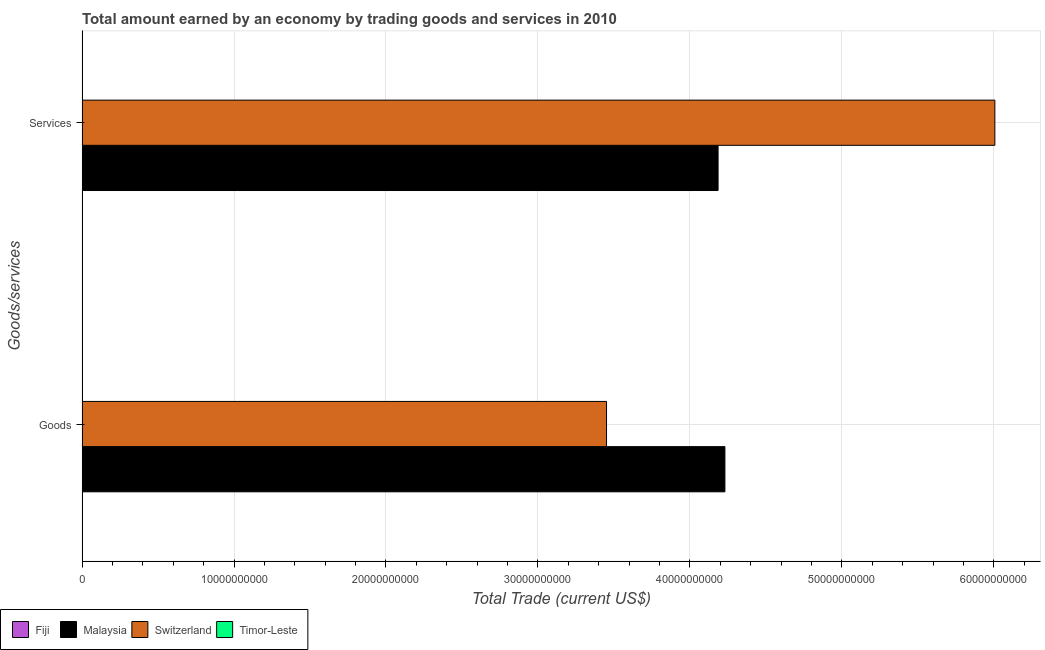How many groups of bars are there?
Make the answer very short. 2. Are the number of bars on each tick of the Y-axis equal?
Your answer should be compact. Yes. How many bars are there on the 1st tick from the top?
Your answer should be very brief. 2. What is the label of the 2nd group of bars from the top?
Offer a terse response. Goods. What is the amount earned by trading services in Timor-Leste?
Provide a succinct answer. 0. Across all countries, what is the maximum amount earned by trading services?
Provide a succinct answer. 6.01e+1. Across all countries, what is the minimum amount earned by trading goods?
Offer a very short reply. 0. In which country was the amount earned by trading services maximum?
Provide a short and direct response. Switzerland. What is the total amount earned by trading services in the graph?
Provide a short and direct response. 1.02e+11. What is the difference between the amount earned by trading goods in Switzerland and that in Malaysia?
Offer a terse response. -7.79e+09. What is the average amount earned by trading goods per country?
Your answer should be compact. 1.92e+1. What is the difference between the amount earned by trading services and amount earned by trading goods in Malaysia?
Offer a terse response. -4.50e+08. What is the ratio of the amount earned by trading goods in Switzerland to that in Malaysia?
Ensure brevity in your answer.  0.82. Is the amount earned by trading services in Malaysia less than that in Switzerland?
Ensure brevity in your answer.  Yes. How many bars are there?
Your answer should be compact. 4. Are all the bars in the graph horizontal?
Your answer should be very brief. Yes. How many countries are there in the graph?
Your answer should be very brief. 4. Are the values on the major ticks of X-axis written in scientific E-notation?
Provide a succinct answer. No. Does the graph contain any zero values?
Give a very brief answer. Yes. Where does the legend appear in the graph?
Give a very brief answer. Bottom left. How many legend labels are there?
Give a very brief answer. 4. What is the title of the graph?
Your answer should be compact. Total amount earned by an economy by trading goods and services in 2010. Does "Libya" appear as one of the legend labels in the graph?
Keep it short and to the point. No. What is the label or title of the X-axis?
Make the answer very short. Total Trade (current US$). What is the label or title of the Y-axis?
Make the answer very short. Goods/services. What is the Total Trade (current US$) in Fiji in Goods?
Offer a terse response. 0. What is the Total Trade (current US$) in Malaysia in Goods?
Ensure brevity in your answer.  4.23e+1. What is the Total Trade (current US$) of Switzerland in Goods?
Your answer should be compact. 3.45e+1. What is the Total Trade (current US$) in Timor-Leste in Goods?
Your answer should be compact. 0. What is the Total Trade (current US$) of Malaysia in Services?
Provide a short and direct response. 4.19e+1. What is the Total Trade (current US$) of Switzerland in Services?
Ensure brevity in your answer.  6.01e+1. Across all Goods/services, what is the maximum Total Trade (current US$) in Malaysia?
Ensure brevity in your answer.  4.23e+1. Across all Goods/services, what is the maximum Total Trade (current US$) in Switzerland?
Keep it short and to the point. 6.01e+1. Across all Goods/services, what is the minimum Total Trade (current US$) of Malaysia?
Your answer should be very brief. 4.19e+1. Across all Goods/services, what is the minimum Total Trade (current US$) of Switzerland?
Offer a terse response. 3.45e+1. What is the total Total Trade (current US$) in Fiji in the graph?
Provide a succinct answer. 0. What is the total Total Trade (current US$) of Malaysia in the graph?
Ensure brevity in your answer.  8.42e+1. What is the total Total Trade (current US$) in Switzerland in the graph?
Provide a succinct answer. 9.46e+1. What is the difference between the Total Trade (current US$) in Malaysia in Goods and that in Services?
Ensure brevity in your answer.  4.50e+08. What is the difference between the Total Trade (current US$) in Switzerland in Goods and that in Services?
Provide a short and direct response. -2.56e+1. What is the difference between the Total Trade (current US$) in Malaysia in Goods and the Total Trade (current US$) in Switzerland in Services?
Your answer should be compact. -1.78e+1. What is the average Total Trade (current US$) in Fiji per Goods/services?
Offer a very short reply. 0. What is the average Total Trade (current US$) of Malaysia per Goods/services?
Provide a short and direct response. 4.21e+1. What is the average Total Trade (current US$) of Switzerland per Goods/services?
Offer a terse response. 4.73e+1. What is the average Total Trade (current US$) in Timor-Leste per Goods/services?
Your response must be concise. 0. What is the difference between the Total Trade (current US$) in Malaysia and Total Trade (current US$) in Switzerland in Goods?
Your response must be concise. 7.79e+09. What is the difference between the Total Trade (current US$) in Malaysia and Total Trade (current US$) in Switzerland in Services?
Give a very brief answer. -1.82e+1. What is the ratio of the Total Trade (current US$) in Malaysia in Goods to that in Services?
Keep it short and to the point. 1.01. What is the ratio of the Total Trade (current US$) of Switzerland in Goods to that in Services?
Your answer should be compact. 0.57. What is the difference between the highest and the second highest Total Trade (current US$) of Malaysia?
Give a very brief answer. 4.50e+08. What is the difference between the highest and the second highest Total Trade (current US$) of Switzerland?
Provide a succinct answer. 2.56e+1. What is the difference between the highest and the lowest Total Trade (current US$) of Malaysia?
Offer a terse response. 4.50e+08. What is the difference between the highest and the lowest Total Trade (current US$) of Switzerland?
Provide a succinct answer. 2.56e+1. 